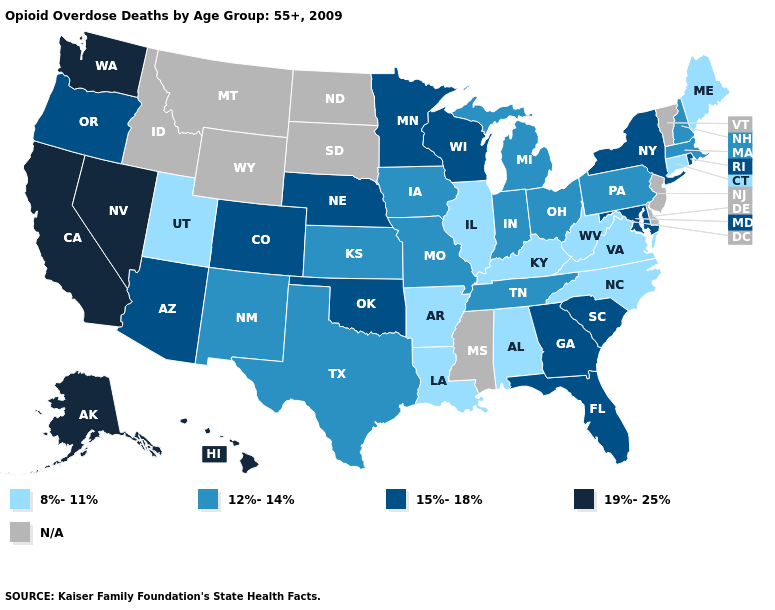What is the lowest value in the West?
Give a very brief answer. 8%-11%. What is the value of Ohio?
Write a very short answer. 12%-14%. Does New York have the lowest value in the USA?
Be succinct. No. Which states have the lowest value in the West?
Give a very brief answer. Utah. How many symbols are there in the legend?
Keep it brief. 5. What is the value of Wyoming?
Write a very short answer. N/A. What is the highest value in the USA?
Concise answer only. 19%-25%. What is the value of Virginia?
Answer briefly. 8%-11%. Name the states that have a value in the range 15%-18%?
Answer briefly. Arizona, Colorado, Florida, Georgia, Maryland, Minnesota, Nebraska, New York, Oklahoma, Oregon, Rhode Island, South Carolina, Wisconsin. Does Nebraska have the highest value in the USA?
Write a very short answer. No. What is the highest value in the USA?
Keep it brief. 19%-25%. What is the value of New Mexico?
Quick response, please. 12%-14%. Name the states that have a value in the range 12%-14%?
Give a very brief answer. Indiana, Iowa, Kansas, Massachusetts, Michigan, Missouri, New Hampshire, New Mexico, Ohio, Pennsylvania, Tennessee, Texas. What is the lowest value in states that border Washington?
Write a very short answer. 15%-18%. Which states hav the highest value in the South?
Quick response, please. Florida, Georgia, Maryland, Oklahoma, South Carolina. 